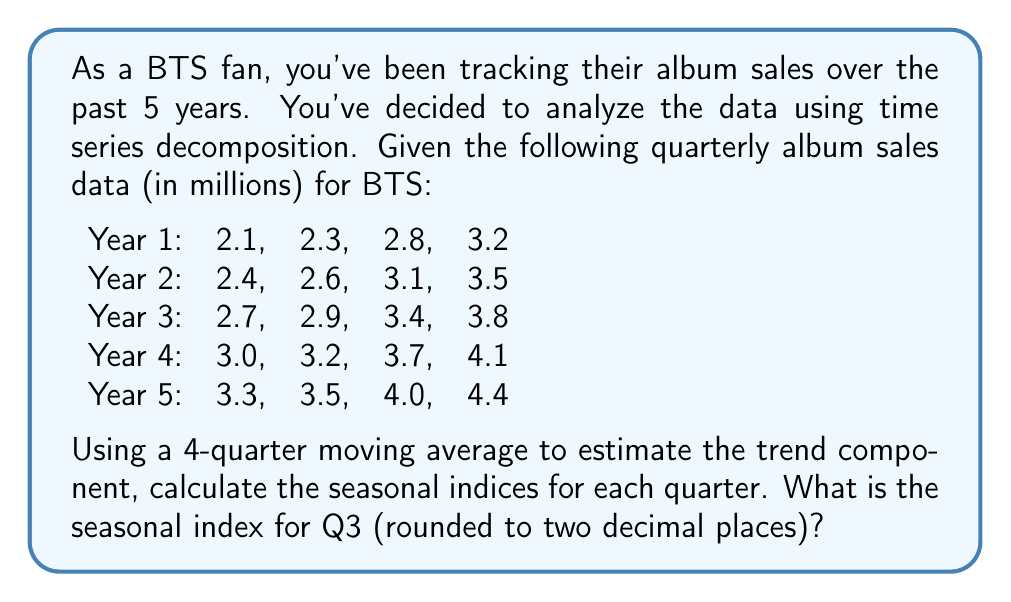Teach me how to tackle this problem. Let's approach this step-by-step:

1) First, we need to calculate the 4-quarter moving average to estimate the trend component.

2) The formula for the 4-quarter moving average is:

   $$MA_t = \frac{Y_{t-2} + Y_{t-1} + Y_t + Y_{t+1}}{4}$$

   where $Y_t$ is the observed value at time $t$.

3) Calculate the moving averages:

   Year 2 Q2: $\frac{2.3 + 2.8 + 3.2 + 2.4}{4} = 2.675$
   Year 2 Q3: $\frac{2.8 + 3.2 + 2.4 + 2.6}{4} = 2.750$
   ...
   Year 4 Q2: $\frac{3.2 + 3.7 + 4.1 + 3.0}{4} = 3.500$

4) Now, we need to calculate the ratio of the actual value to the moving average for each quarter:

   Year 2 Q2: $\frac{2.6}{2.675} = 0.972$
   Year 2 Q3: $\frac{3.1}{2.750} = 1.127$
   ...
   Year 4 Q2: $\frac{3.2}{3.500} = 0.914$

5) Group these ratios by quarter and calculate the average for each quarter:

   Q1: $(0.889 + 0.900 + 0.909) \div 3 = 0.899$
   Q2: $(0.972 + 0.935 + 0.914) \div 3 = 0.940$
   Q3: $(1.127 + 1.084 + 1.057) \div 3 = 1.089$
   Q4: $(1.217 + 1.171 + 1.139) \div 3 = 1.176$

6) These averages are our seasonal indices. For Q3, the seasonal index is 1.089.

7) Rounding to two decimal places gives us 1.09.
Answer: 1.09 